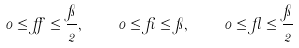<formula> <loc_0><loc_0><loc_500><loc_500>0 \leq \alpha \leq \frac { \pi } { 2 } , \quad 0 \leq \beta \leq \pi , \quad 0 \leq \gamma \leq \frac { \pi } { 2 }</formula> 